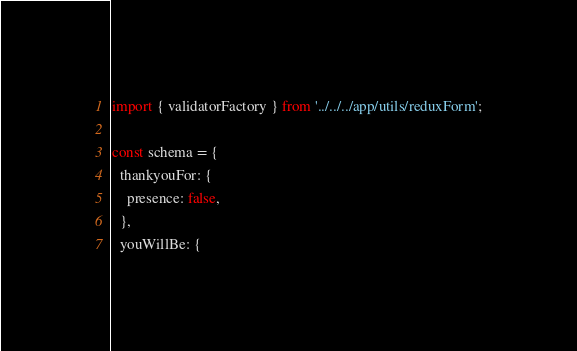Convert code to text. <code><loc_0><loc_0><loc_500><loc_500><_JavaScript_>import { validatorFactory } from '../../../app/utils/reduxForm';

const schema = {
  thankyouFor: {
    presence: false,
  },
  youWillBe: {</code> 